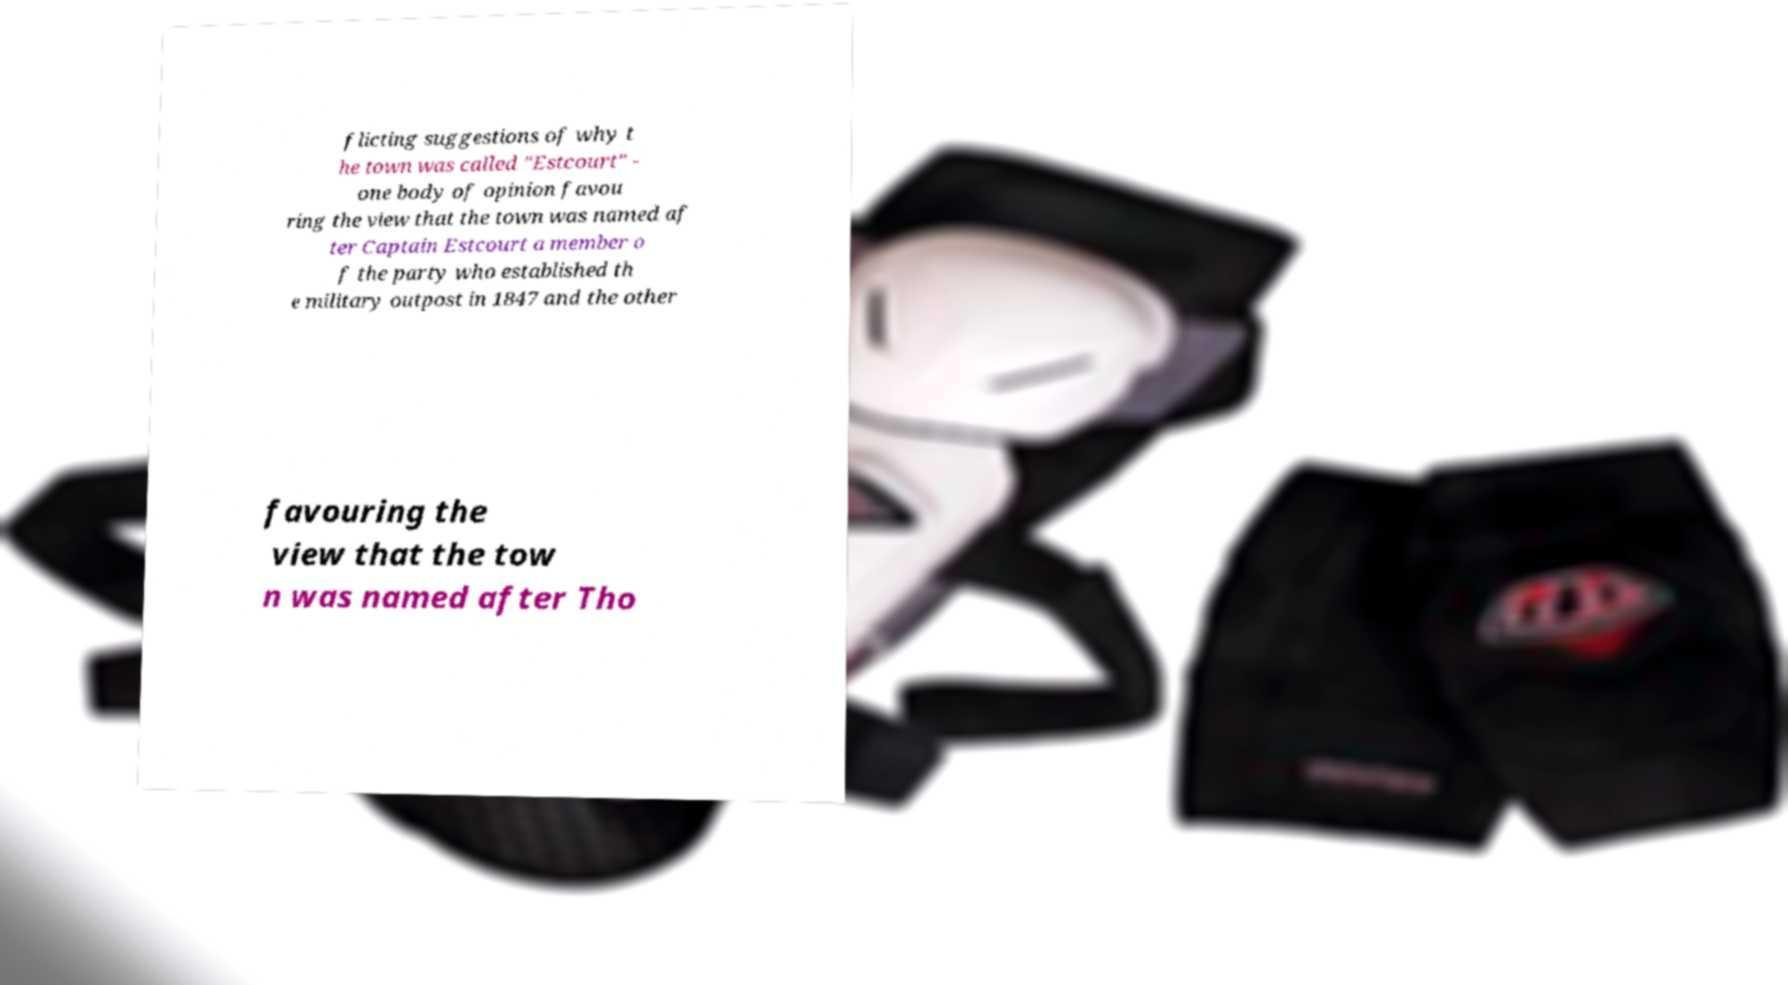Can you read and provide the text displayed in the image?This photo seems to have some interesting text. Can you extract and type it out for me? flicting suggestions of why t he town was called "Estcourt" - one body of opinion favou ring the view that the town was named af ter Captain Estcourt a member o f the party who established th e military outpost in 1847 and the other favouring the view that the tow n was named after Tho 